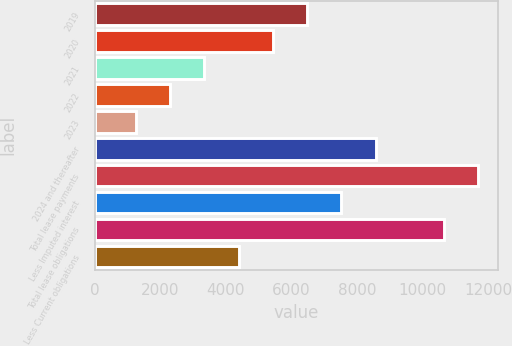Convert chart. <chart><loc_0><loc_0><loc_500><loc_500><bar_chart><fcel>2019<fcel>2020<fcel>2021<fcel>2022<fcel>2023<fcel>2024 and thereafter<fcel>Total lease payments<fcel>Less Imputed interest<fcel>Total lease obligations<fcel>Less Current obligations<nl><fcel>6477<fcel>5432.6<fcel>3343.8<fcel>2299.4<fcel>1255<fcel>8565.8<fcel>11699<fcel>7521.4<fcel>10654.6<fcel>4388.2<nl></chart> 